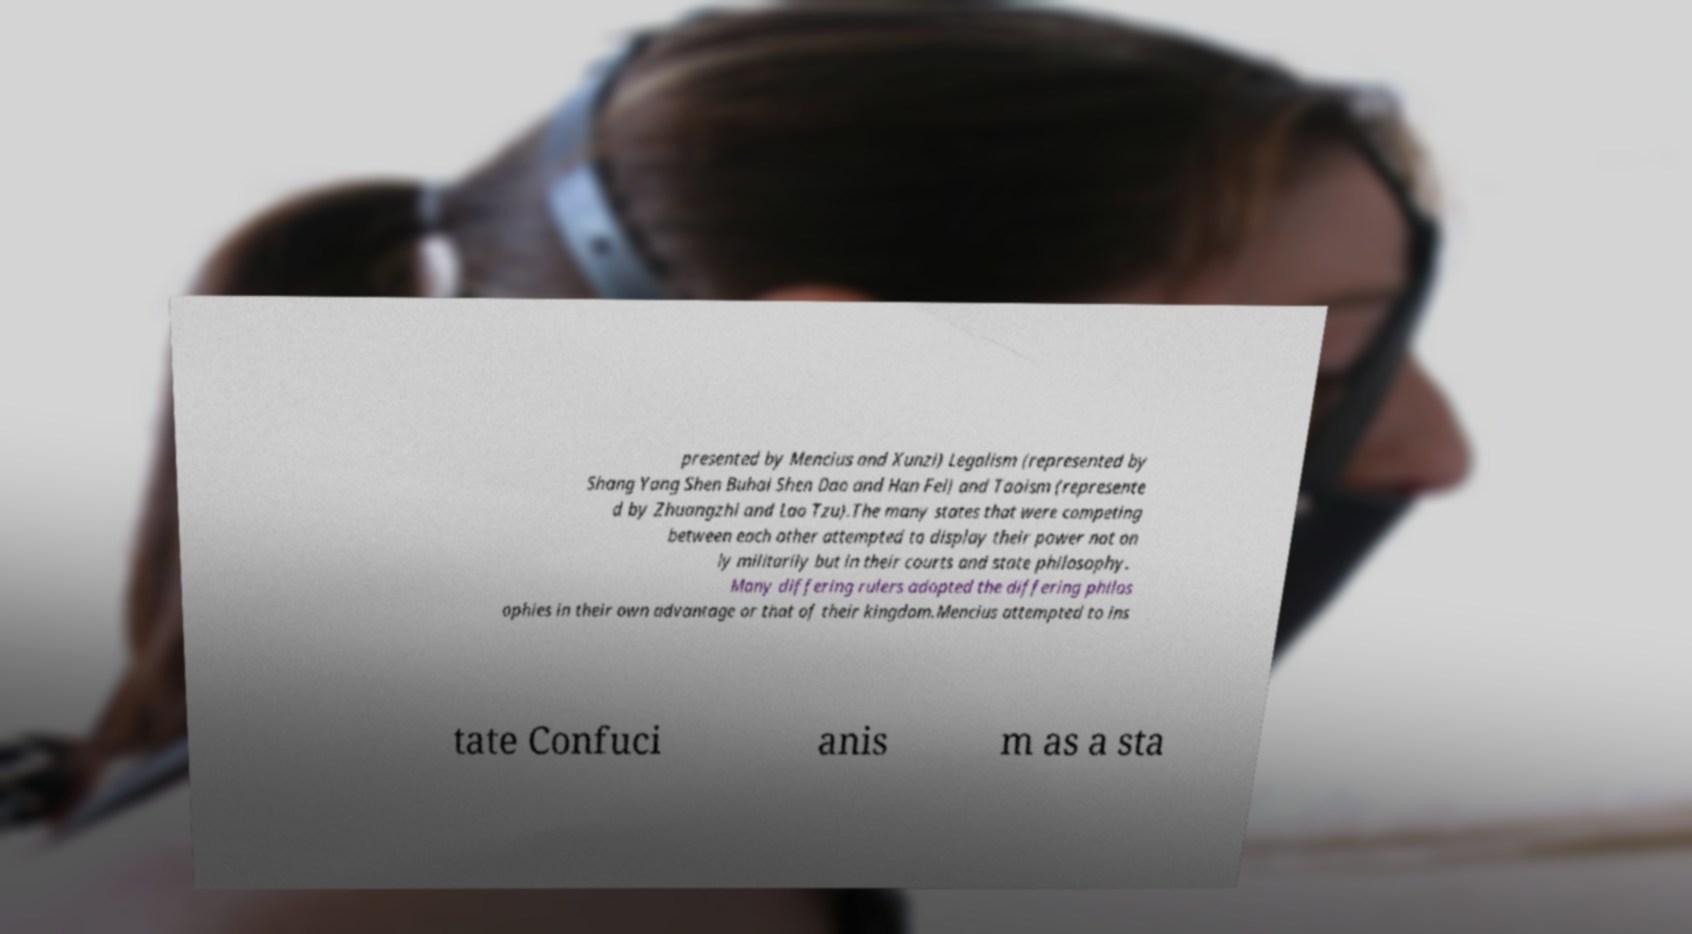Could you assist in decoding the text presented in this image and type it out clearly? presented by Mencius and Xunzi) Legalism (represented by Shang Yang Shen Buhai Shen Dao and Han Fei) and Taoism (represente d by Zhuangzhi and Lao Tzu).The many states that were competing between each other attempted to display their power not on ly militarily but in their courts and state philosophy. Many differing rulers adopted the differing philos ophies in their own advantage or that of their kingdom.Mencius attempted to ins tate Confuci anis m as a sta 